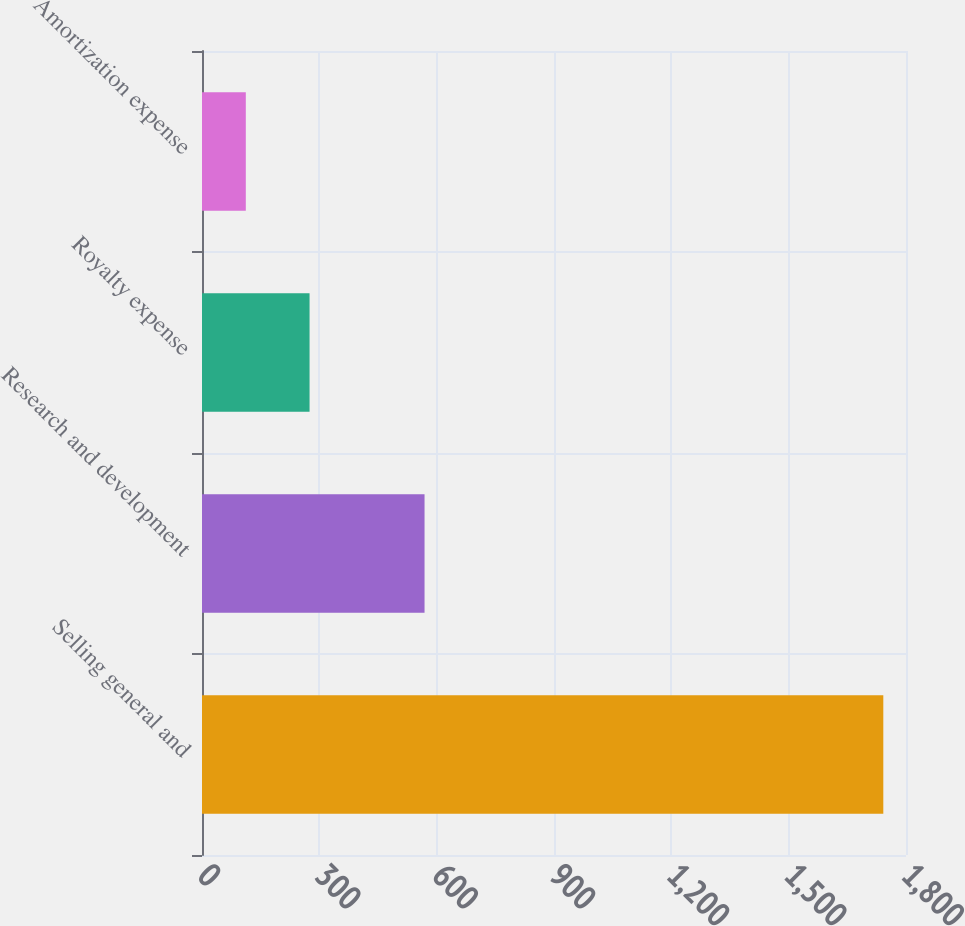Convert chart. <chart><loc_0><loc_0><loc_500><loc_500><bar_chart><fcel>Selling general and<fcel>Research and development<fcel>Royalty expense<fcel>Amortization expense<nl><fcel>1742<fcel>569<fcel>275<fcel>112<nl></chart> 